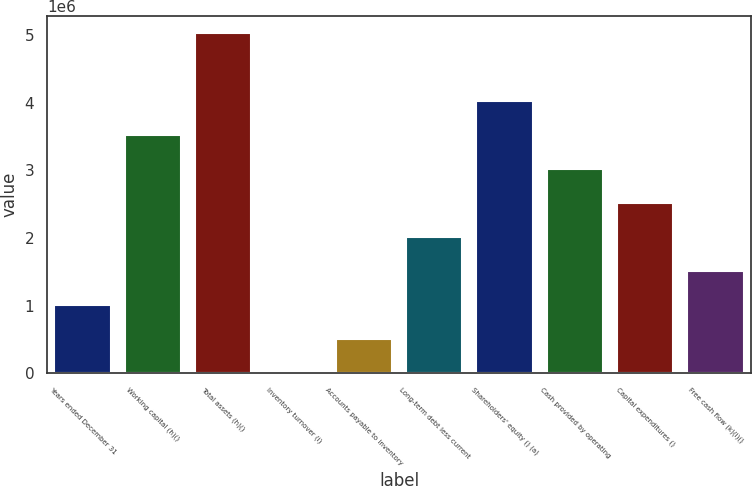Convert chart. <chart><loc_0><loc_0><loc_500><loc_500><bar_chart><fcel>Years ended December 31<fcel>Working capital (h)()<fcel>Total assets (h)()<fcel>Inventory turnover (i)<fcel>Accounts payable to inventory<fcel>Long-term debt less current<fcel>Shareholders' equity () (a)<fcel>Cash provided by operating<fcel>Capital expenditures ()<fcel>Free cash flow (k)(l)()<nl><fcel>1.00639e+06<fcel>3.52237e+06<fcel>5.03195e+06<fcel>1.4<fcel>503196<fcel>2.01278e+06<fcel>4.02556e+06<fcel>3.01917e+06<fcel>2.51598e+06<fcel>1.50959e+06<nl></chart> 